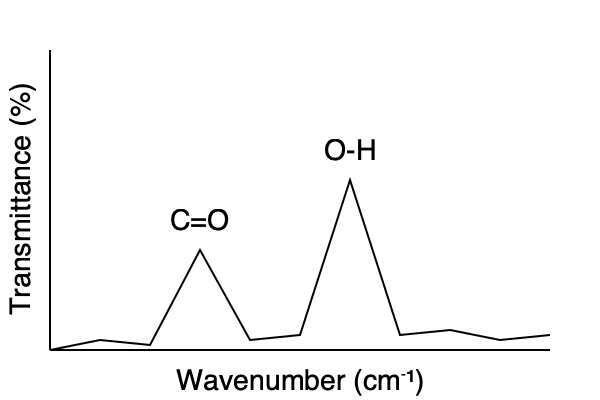Analyze the given infrared spectroscopy graph and identify the functional groups present in the molecule. What type of organic compound is most likely represented by this spectrum? To identify the functional groups and determine the type of organic compound, we need to analyze the characteristic peaks in the IR spectrum:

1. O-H stretch: There is a broad, strong peak around 3400 cm⁻¹ (3300-3600 cm⁻¹ range). This is characteristic of an O-H bond, typically found in alcohols or carboxylic acids.

2. C=O stretch: There is a strong, sharp peak around 1700 cm⁻¹ (1670-1780 cm⁻¹ range). This indicates the presence of a carbonyl group (C=O).

3. The combination of a strong O-H stretch and a C=O stretch suggests the presence of a carboxylic acid group (-COOH).

4. There are no other significant peaks that would indicate the presence of other functional groups.

Given this information, we can conclude that the spectrum most likely represents a carboxylic acid. Carboxylic acids contain both an O-H group and a C=O group in the same functional group (-COOH), which matches the observed peaks in the spectrum.
Answer: Carboxylic acid 